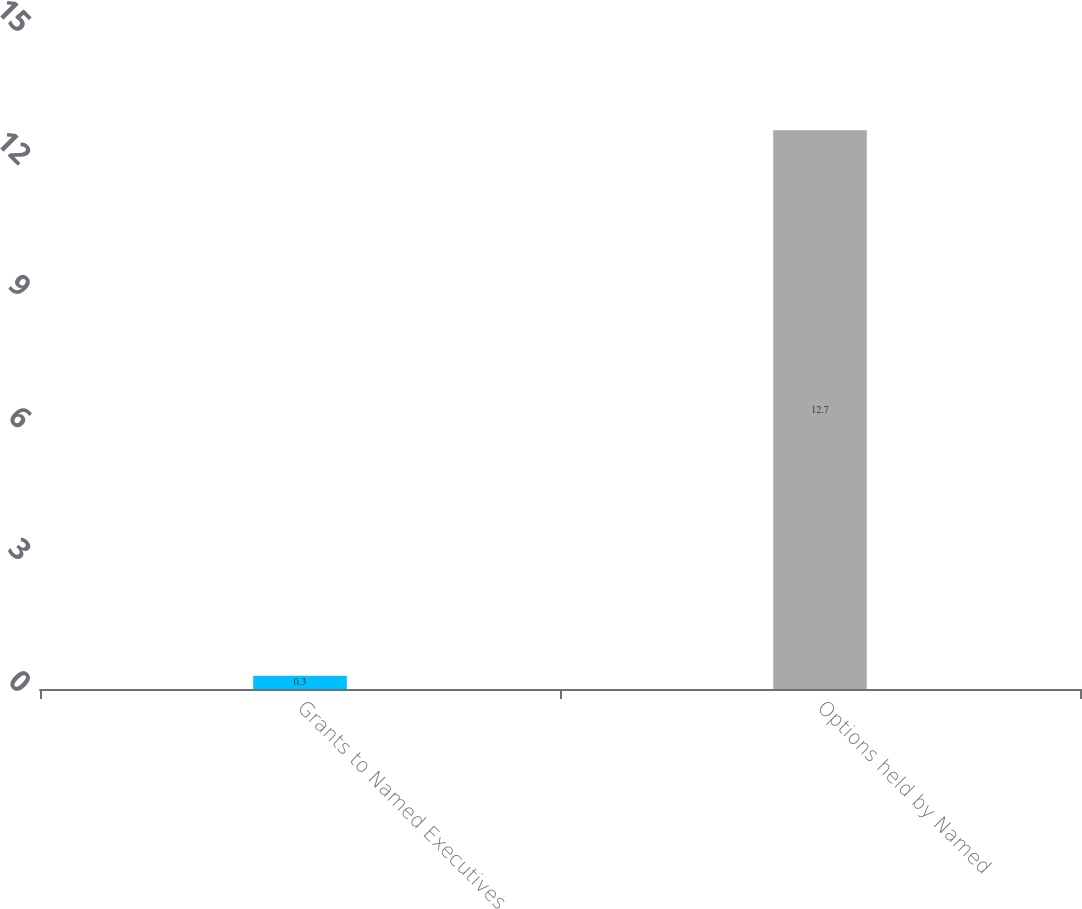Convert chart to OTSL. <chart><loc_0><loc_0><loc_500><loc_500><bar_chart><fcel>Grants to Named Executives<fcel>Options held by Named<nl><fcel>0.3<fcel>12.7<nl></chart> 